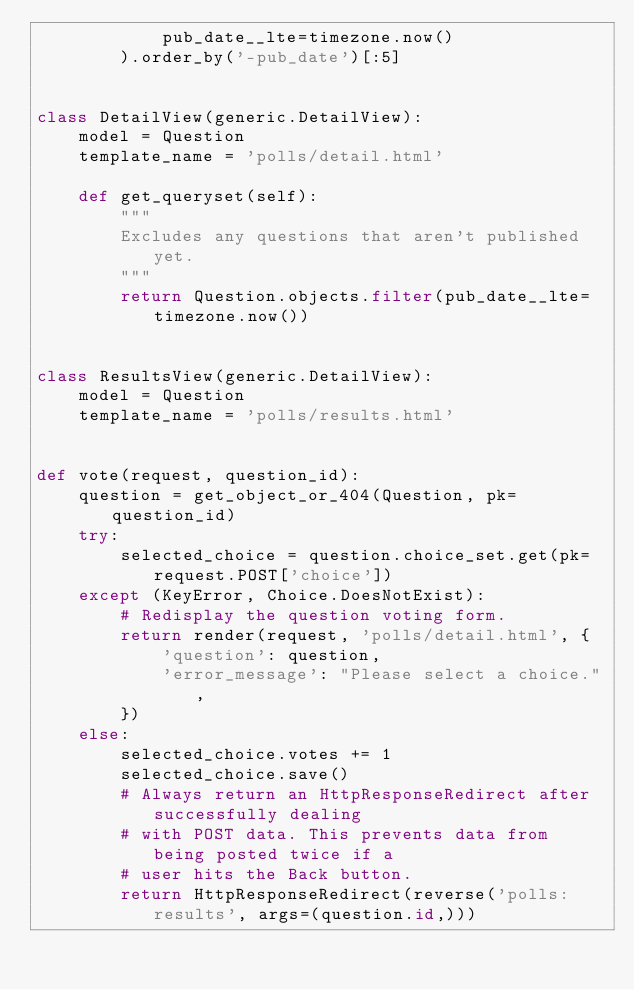<code> <loc_0><loc_0><loc_500><loc_500><_Python_>            pub_date__lte=timezone.now()
        ).order_by('-pub_date')[:5]


class DetailView(generic.DetailView):
    model = Question
    template_name = 'polls/detail.html'

    def get_queryset(self):
        """
        Excludes any questions that aren't published yet.
        """
        return Question.objects.filter(pub_date__lte=timezone.now())


class ResultsView(generic.DetailView):
    model = Question
    template_name = 'polls/results.html'


def vote(request, question_id):
    question = get_object_or_404(Question, pk=question_id)
    try:
        selected_choice = question.choice_set.get(pk=request.POST['choice'])
    except (KeyError, Choice.DoesNotExist):
        # Redisplay the question voting form.
        return render(request, 'polls/detail.html', {
            'question': question,
            'error_message': "Please select a choice.",
        })
    else:
        selected_choice.votes += 1
        selected_choice.save()
        # Always return an HttpResponseRedirect after successfully dealing
        # with POST data. This prevents data from being posted twice if a
        # user hits the Back button.
        return HttpResponseRedirect(reverse('polls:results', args=(question.id,)))</code> 